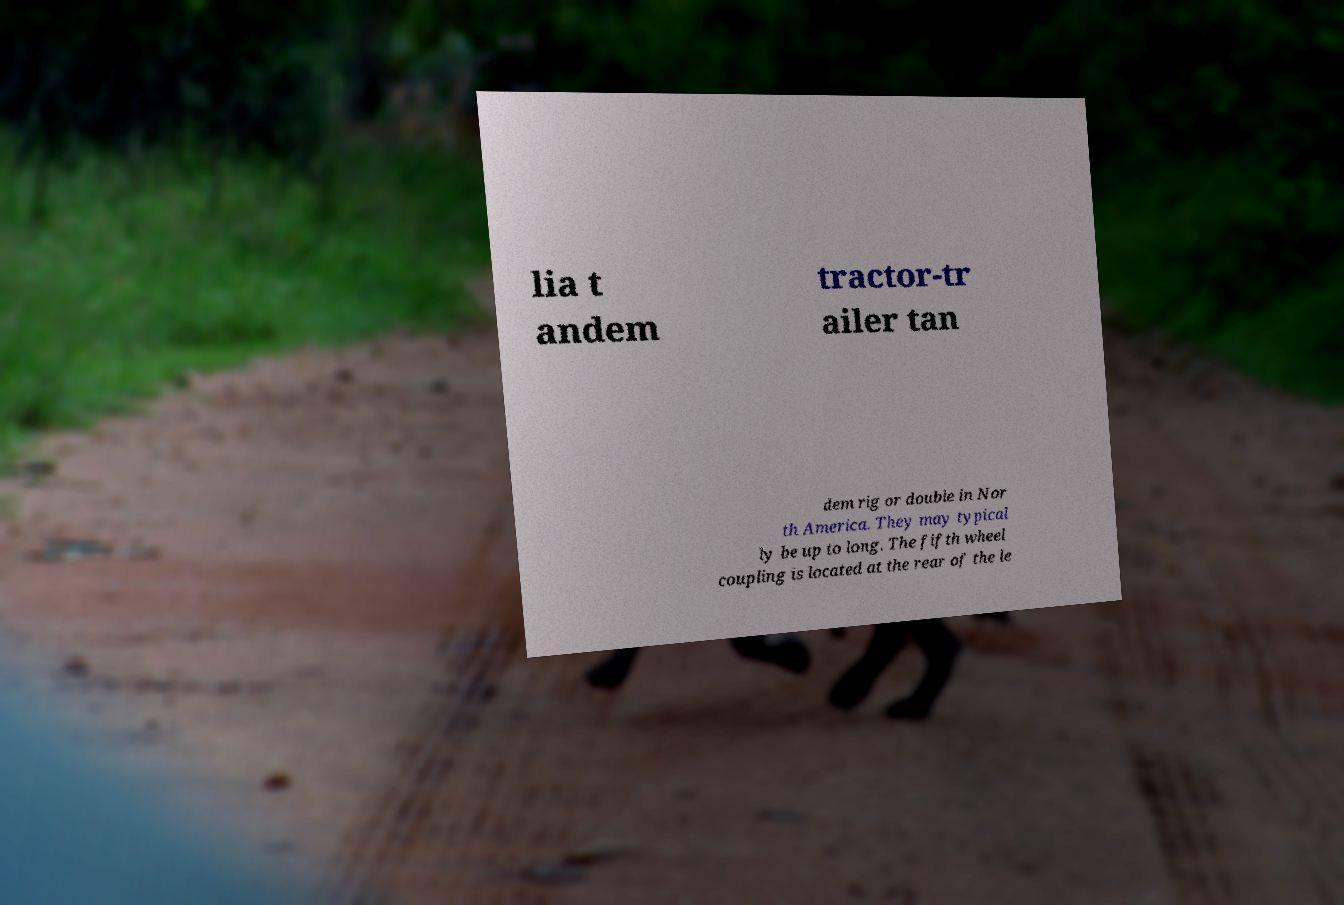Please identify and transcribe the text found in this image. lia t andem tractor-tr ailer tan dem rig or double in Nor th America. They may typical ly be up to long. The fifth wheel coupling is located at the rear of the le 